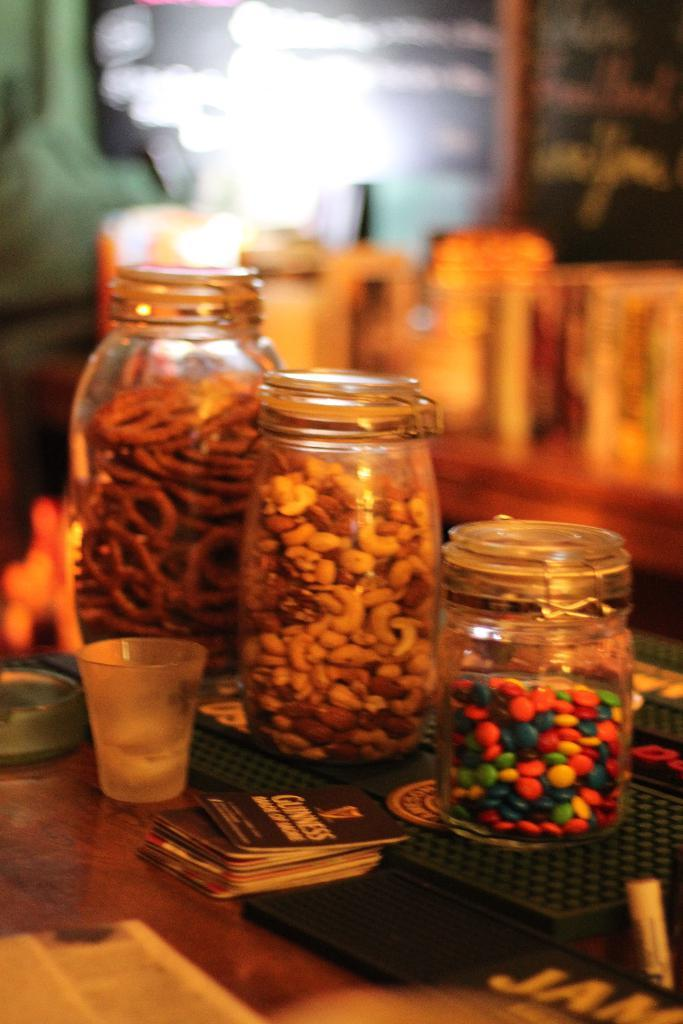What type of containers are visible in the image? There are glass jars in the image. Where are the glass jars located? The glass jars are placed on a table. What is inside the glass jars? There is food in the glass jars. Can you describe the background of the image? The background of the image is blurred. What type of mitten is being used to serve the food in the image? There is no mitten present in the image; the food is in glass jars on a table. 